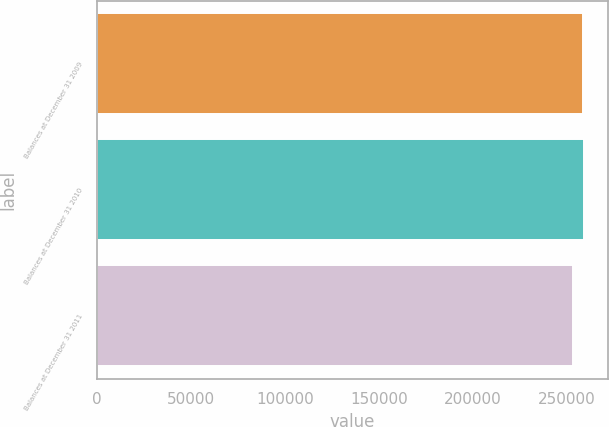<chart> <loc_0><loc_0><loc_500><loc_500><bar_chart><fcel>Balances at December 31 2009<fcel>Balances at December 31 2010<fcel>Balances at December 31 2011<nl><fcel>258534<fcel>259083<fcel>253272<nl></chart> 